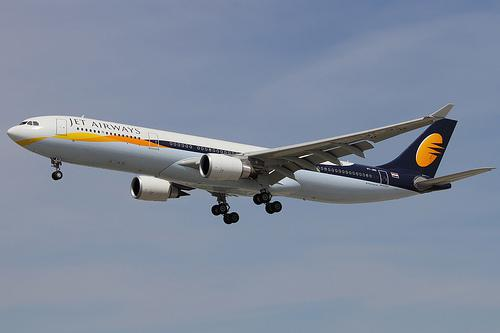Question: where was the photo taken?
Choices:
A. From a ballon.
B. Out of a plane's window.
C. In the air.
D. From the mountain top.
Answer with the letter. Answer: C Question: what mode of transportation is shown?
Choices:
A. Car.
B. Plane.
C. Train.
D. Motorcycle.
Answer with the letter. Answer: B Question: where are the windows?
Choices:
A. SIde of the house.
B. Side of the car.
C. Side of the train.
D. Side of the plane.
Answer with the letter. Answer: D Question: what are the words on the plane?
Choices:
A. American Airlines.
B. Delta Airlines.
C. Jet Airways.
D. British Airways.
Answer with the letter. Answer: C Question: how many doors are shown?
Choices:
A. 3.
B. 12.
C. 13.
D. 5.
Answer with the letter. Answer: A 